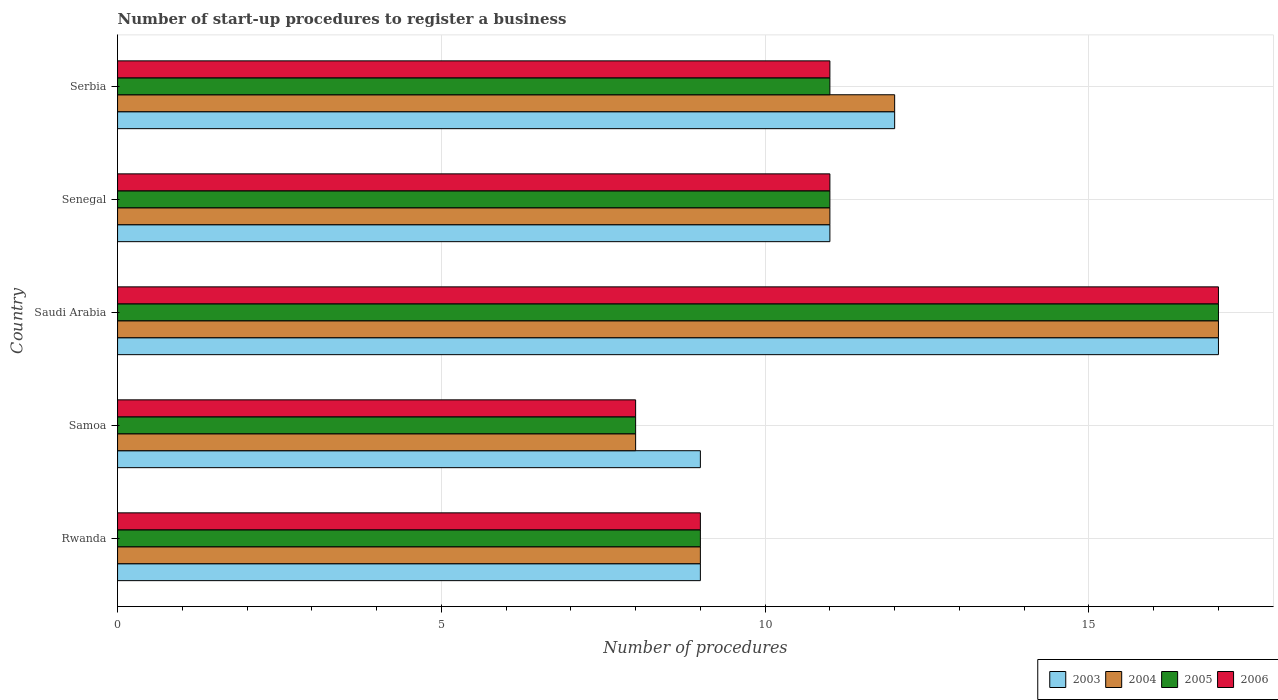How many different coloured bars are there?
Provide a succinct answer. 4. How many groups of bars are there?
Make the answer very short. 5. Are the number of bars per tick equal to the number of legend labels?
Keep it short and to the point. Yes. Are the number of bars on each tick of the Y-axis equal?
Offer a very short reply. Yes. How many bars are there on the 1st tick from the bottom?
Your answer should be very brief. 4. What is the label of the 3rd group of bars from the top?
Your response must be concise. Saudi Arabia. In how many cases, is the number of bars for a given country not equal to the number of legend labels?
Your answer should be very brief. 0. What is the number of procedures required to register a business in 2004 in Rwanda?
Provide a succinct answer. 9. In which country was the number of procedures required to register a business in 2006 maximum?
Make the answer very short. Saudi Arabia. In which country was the number of procedures required to register a business in 2006 minimum?
Give a very brief answer. Samoa. What is the difference between the number of procedures required to register a business in 2006 in Rwanda and that in Saudi Arabia?
Ensure brevity in your answer.  -8. What is the average number of procedures required to register a business in 2006 per country?
Your response must be concise. 11.2. What is the ratio of the number of procedures required to register a business in 2005 in Samoa to that in Serbia?
Offer a very short reply. 0.73. Is the number of procedures required to register a business in 2006 in Samoa less than that in Saudi Arabia?
Your answer should be very brief. Yes. Is the difference between the number of procedures required to register a business in 2005 in Samoa and Saudi Arabia greater than the difference between the number of procedures required to register a business in 2004 in Samoa and Saudi Arabia?
Offer a very short reply. No. What is the difference between the highest and the second highest number of procedures required to register a business in 2003?
Offer a very short reply. 5. What is the difference between the highest and the lowest number of procedures required to register a business in 2003?
Ensure brevity in your answer.  8. In how many countries, is the number of procedures required to register a business in 2003 greater than the average number of procedures required to register a business in 2003 taken over all countries?
Your answer should be very brief. 2. How many bars are there?
Provide a succinct answer. 20. What is the difference between two consecutive major ticks on the X-axis?
Your response must be concise. 5. Are the values on the major ticks of X-axis written in scientific E-notation?
Give a very brief answer. No. Does the graph contain grids?
Provide a short and direct response. Yes. Where does the legend appear in the graph?
Offer a terse response. Bottom right. How many legend labels are there?
Your response must be concise. 4. How are the legend labels stacked?
Give a very brief answer. Horizontal. What is the title of the graph?
Your answer should be very brief. Number of start-up procedures to register a business. Does "1974" appear as one of the legend labels in the graph?
Offer a terse response. No. What is the label or title of the X-axis?
Your answer should be compact. Number of procedures. What is the Number of procedures in 2006 in Rwanda?
Offer a terse response. 9. What is the Number of procedures of 2005 in Samoa?
Your response must be concise. 8. What is the Number of procedures in 2003 in Saudi Arabia?
Provide a succinct answer. 17. What is the Number of procedures of 2006 in Saudi Arabia?
Offer a very short reply. 17. What is the Number of procedures of 2004 in Serbia?
Offer a terse response. 12. Across all countries, what is the maximum Number of procedures of 2003?
Offer a terse response. 17. Across all countries, what is the maximum Number of procedures in 2004?
Your answer should be very brief. 17. Across all countries, what is the maximum Number of procedures of 2005?
Your answer should be very brief. 17. Across all countries, what is the maximum Number of procedures of 2006?
Provide a succinct answer. 17. Across all countries, what is the minimum Number of procedures of 2003?
Offer a terse response. 9. Across all countries, what is the minimum Number of procedures in 2005?
Give a very brief answer. 8. Across all countries, what is the minimum Number of procedures of 2006?
Offer a very short reply. 8. What is the total Number of procedures in 2006 in the graph?
Your answer should be compact. 56. What is the difference between the Number of procedures of 2004 in Rwanda and that in Samoa?
Keep it short and to the point. 1. What is the difference between the Number of procedures of 2005 in Rwanda and that in Samoa?
Ensure brevity in your answer.  1. What is the difference between the Number of procedures in 2006 in Rwanda and that in Samoa?
Ensure brevity in your answer.  1. What is the difference between the Number of procedures in 2006 in Rwanda and that in Saudi Arabia?
Offer a terse response. -8. What is the difference between the Number of procedures in 2003 in Rwanda and that in Senegal?
Your response must be concise. -2. What is the difference between the Number of procedures of 2004 in Rwanda and that in Senegal?
Ensure brevity in your answer.  -2. What is the difference between the Number of procedures in 2005 in Rwanda and that in Senegal?
Your answer should be compact. -2. What is the difference between the Number of procedures of 2004 in Rwanda and that in Serbia?
Give a very brief answer. -3. What is the difference between the Number of procedures in 2005 in Rwanda and that in Serbia?
Keep it short and to the point. -2. What is the difference between the Number of procedures in 2006 in Rwanda and that in Serbia?
Give a very brief answer. -2. What is the difference between the Number of procedures in 2005 in Samoa and that in Saudi Arabia?
Offer a terse response. -9. What is the difference between the Number of procedures in 2004 in Samoa and that in Senegal?
Provide a short and direct response. -3. What is the difference between the Number of procedures in 2005 in Samoa and that in Senegal?
Provide a short and direct response. -3. What is the difference between the Number of procedures in 2006 in Samoa and that in Senegal?
Make the answer very short. -3. What is the difference between the Number of procedures of 2004 in Samoa and that in Serbia?
Offer a terse response. -4. What is the difference between the Number of procedures in 2006 in Samoa and that in Serbia?
Provide a short and direct response. -3. What is the difference between the Number of procedures in 2004 in Saudi Arabia and that in Senegal?
Give a very brief answer. 6. What is the difference between the Number of procedures in 2005 in Saudi Arabia and that in Senegal?
Offer a terse response. 6. What is the difference between the Number of procedures of 2005 in Saudi Arabia and that in Serbia?
Make the answer very short. 6. What is the difference between the Number of procedures of 2006 in Saudi Arabia and that in Serbia?
Give a very brief answer. 6. What is the difference between the Number of procedures of 2005 in Senegal and that in Serbia?
Provide a short and direct response. 0. What is the difference between the Number of procedures in 2003 in Rwanda and the Number of procedures in 2004 in Samoa?
Keep it short and to the point. 1. What is the difference between the Number of procedures in 2003 in Rwanda and the Number of procedures in 2005 in Samoa?
Keep it short and to the point. 1. What is the difference between the Number of procedures of 2003 in Rwanda and the Number of procedures of 2006 in Samoa?
Offer a very short reply. 1. What is the difference between the Number of procedures of 2004 in Rwanda and the Number of procedures of 2006 in Samoa?
Your response must be concise. 1. What is the difference between the Number of procedures of 2003 in Rwanda and the Number of procedures of 2004 in Saudi Arabia?
Offer a very short reply. -8. What is the difference between the Number of procedures of 2003 in Rwanda and the Number of procedures of 2005 in Saudi Arabia?
Make the answer very short. -8. What is the difference between the Number of procedures in 2004 in Rwanda and the Number of procedures in 2005 in Saudi Arabia?
Provide a short and direct response. -8. What is the difference between the Number of procedures in 2005 in Rwanda and the Number of procedures in 2006 in Saudi Arabia?
Your answer should be compact. -8. What is the difference between the Number of procedures of 2003 in Rwanda and the Number of procedures of 2004 in Senegal?
Make the answer very short. -2. What is the difference between the Number of procedures of 2004 in Rwanda and the Number of procedures of 2005 in Senegal?
Give a very brief answer. -2. What is the difference between the Number of procedures in 2004 in Rwanda and the Number of procedures in 2006 in Senegal?
Give a very brief answer. -2. What is the difference between the Number of procedures in 2005 in Rwanda and the Number of procedures in 2006 in Senegal?
Offer a very short reply. -2. What is the difference between the Number of procedures in 2003 in Rwanda and the Number of procedures in 2004 in Serbia?
Your answer should be compact. -3. What is the difference between the Number of procedures of 2003 in Rwanda and the Number of procedures of 2005 in Serbia?
Offer a very short reply. -2. What is the difference between the Number of procedures in 2004 in Rwanda and the Number of procedures in 2005 in Serbia?
Offer a very short reply. -2. What is the difference between the Number of procedures of 2004 in Rwanda and the Number of procedures of 2006 in Serbia?
Provide a short and direct response. -2. What is the difference between the Number of procedures of 2005 in Rwanda and the Number of procedures of 2006 in Serbia?
Offer a very short reply. -2. What is the difference between the Number of procedures of 2003 in Samoa and the Number of procedures of 2006 in Saudi Arabia?
Your answer should be compact. -8. What is the difference between the Number of procedures in 2004 in Samoa and the Number of procedures in 2005 in Saudi Arabia?
Ensure brevity in your answer.  -9. What is the difference between the Number of procedures in 2003 in Samoa and the Number of procedures in 2005 in Senegal?
Your response must be concise. -2. What is the difference between the Number of procedures of 2005 in Samoa and the Number of procedures of 2006 in Senegal?
Offer a very short reply. -3. What is the difference between the Number of procedures of 2003 in Samoa and the Number of procedures of 2006 in Serbia?
Provide a short and direct response. -2. What is the difference between the Number of procedures of 2004 in Samoa and the Number of procedures of 2005 in Serbia?
Offer a terse response. -3. What is the difference between the Number of procedures in 2004 in Samoa and the Number of procedures in 2006 in Serbia?
Provide a succinct answer. -3. What is the difference between the Number of procedures of 2005 in Samoa and the Number of procedures of 2006 in Serbia?
Give a very brief answer. -3. What is the difference between the Number of procedures in 2003 in Saudi Arabia and the Number of procedures in 2006 in Senegal?
Your response must be concise. 6. What is the difference between the Number of procedures in 2005 in Saudi Arabia and the Number of procedures in 2006 in Senegal?
Provide a succinct answer. 6. What is the difference between the Number of procedures in 2003 in Saudi Arabia and the Number of procedures in 2004 in Serbia?
Your answer should be compact. 5. What is the difference between the Number of procedures of 2003 in Saudi Arabia and the Number of procedures of 2005 in Serbia?
Provide a succinct answer. 6. What is the difference between the Number of procedures in 2004 in Saudi Arabia and the Number of procedures in 2005 in Serbia?
Your answer should be compact. 6. What is the difference between the Number of procedures in 2004 in Saudi Arabia and the Number of procedures in 2006 in Serbia?
Your answer should be compact. 6. What is the difference between the Number of procedures of 2005 in Saudi Arabia and the Number of procedures of 2006 in Serbia?
Make the answer very short. 6. What is the difference between the Number of procedures in 2003 in Senegal and the Number of procedures in 2004 in Serbia?
Provide a succinct answer. -1. What is the difference between the Number of procedures of 2003 in Senegal and the Number of procedures of 2005 in Serbia?
Provide a short and direct response. 0. What is the difference between the Number of procedures in 2003 in Senegal and the Number of procedures in 2006 in Serbia?
Give a very brief answer. 0. What is the difference between the Number of procedures in 2005 in Senegal and the Number of procedures in 2006 in Serbia?
Offer a terse response. 0. What is the average Number of procedures of 2003 per country?
Give a very brief answer. 11.6. What is the average Number of procedures in 2004 per country?
Give a very brief answer. 11.4. What is the average Number of procedures of 2006 per country?
Keep it short and to the point. 11.2. What is the difference between the Number of procedures of 2003 and Number of procedures of 2005 in Rwanda?
Give a very brief answer. 0. What is the difference between the Number of procedures in 2004 and Number of procedures in 2005 in Rwanda?
Ensure brevity in your answer.  0. What is the difference between the Number of procedures of 2003 and Number of procedures of 2006 in Samoa?
Your answer should be very brief. 1. What is the difference between the Number of procedures in 2003 and Number of procedures in 2005 in Saudi Arabia?
Offer a terse response. 0. What is the difference between the Number of procedures of 2003 and Number of procedures of 2006 in Saudi Arabia?
Your answer should be compact. 0. What is the difference between the Number of procedures in 2004 and Number of procedures in 2005 in Saudi Arabia?
Provide a short and direct response. 0. What is the difference between the Number of procedures of 2003 and Number of procedures of 2005 in Senegal?
Offer a very short reply. 0. What is the difference between the Number of procedures of 2003 and Number of procedures of 2006 in Senegal?
Your response must be concise. 0. What is the difference between the Number of procedures of 2004 and Number of procedures of 2005 in Senegal?
Offer a very short reply. 0. What is the difference between the Number of procedures of 2004 and Number of procedures of 2006 in Senegal?
Offer a terse response. 0. What is the difference between the Number of procedures in 2003 and Number of procedures in 2004 in Serbia?
Offer a very short reply. 0. What is the difference between the Number of procedures in 2003 and Number of procedures in 2005 in Serbia?
Your response must be concise. 1. What is the difference between the Number of procedures of 2003 and Number of procedures of 2006 in Serbia?
Make the answer very short. 1. What is the difference between the Number of procedures in 2004 and Number of procedures in 2005 in Serbia?
Your answer should be very brief. 1. What is the difference between the Number of procedures of 2005 and Number of procedures of 2006 in Serbia?
Keep it short and to the point. 0. What is the ratio of the Number of procedures of 2003 in Rwanda to that in Samoa?
Provide a short and direct response. 1. What is the ratio of the Number of procedures in 2006 in Rwanda to that in Samoa?
Provide a succinct answer. 1.12. What is the ratio of the Number of procedures in 2003 in Rwanda to that in Saudi Arabia?
Your answer should be compact. 0.53. What is the ratio of the Number of procedures of 2004 in Rwanda to that in Saudi Arabia?
Your answer should be compact. 0.53. What is the ratio of the Number of procedures in 2005 in Rwanda to that in Saudi Arabia?
Provide a short and direct response. 0.53. What is the ratio of the Number of procedures in 2006 in Rwanda to that in Saudi Arabia?
Give a very brief answer. 0.53. What is the ratio of the Number of procedures of 2003 in Rwanda to that in Senegal?
Make the answer very short. 0.82. What is the ratio of the Number of procedures in 2004 in Rwanda to that in Senegal?
Provide a short and direct response. 0.82. What is the ratio of the Number of procedures of 2005 in Rwanda to that in Senegal?
Offer a very short reply. 0.82. What is the ratio of the Number of procedures of 2006 in Rwanda to that in Senegal?
Your response must be concise. 0.82. What is the ratio of the Number of procedures in 2004 in Rwanda to that in Serbia?
Provide a short and direct response. 0.75. What is the ratio of the Number of procedures of 2005 in Rwanda to that in Serbia?
Your response must be concise. 0.82. What is the ratio of the Number of procedures of 2006 in Rwanda to that in Serbia?
Offer a terse response. 0.82. What is the ratio of the Number of procedures of 2003 in Samoa to that in Saudi Arabia?
Keep it short and to the point. 0.53. What is the ratio of the Number of procedures of 2004 in Samoa to that in Saudi Arabia?
Keep it short and to the point. 0.47. What is the ratio of the Number of procedures of 2005 in Samoa to that in Saudi Arabia?
Offer a very short reply. 0.47. What is the ratio of the Number of procedures of 2006 in Samoa to that in Saudi Arabia?
Offer a very short reply. 0.47. What is the ratio of the Number of procedures of 2003 in Samoa to that in Senegal?
Make the answer very short. 0.82. What is the ratio of the Number of procedures of 2004 in Samoa to that in Senegal?
Provide a short and direct response. 0.73. What is the ratio of the Number of procedures in 2005 in Samoa to that in Senegal?
Make the answer very short. 0.73. What is the ratio of the Number of procedures in 2006 in Samoa to that in Senegal?
Give a very brief answer. 0.73. What is the ratio of the Number of procedures of 2004 in Samoa to that in Serbia?
Provide a short and direct response. 0.67. What is the ratio of the Number of procedures of 2005 in Samoa to that in Serbia?
Provide a succinct answer. 0.73. What is the ratio of the Number of procedures in 2006 in Samoa to that in Serbia?
Your answer should be compact. 0.73. What is the ratio of the Number of procedures of 2003 in Saudi Arabia to that in Senegal?
Provide a succinct answer. 1.55. What is the ratio of the Number of procedures of 2004 in Saudi Arabia to that in Senegal?
Keep it short and to the point. 1.55. What is the ratio of the Number of procedures in 2005 in Saudi Arabia to that in Senegal?
Ensure brevity in your answer.  1.55. What is the ratio of the Number of procedures of 2006 in Saudi Arabia to that in Senegal?
Keep it short and to the point. 1.55. What is the ratio of the Number of procedures of 2003 in Saudi Arabia to that in Serbia?
Your answer should be compact. 1.42. What is the ratio of the Number of procedures in 2004 in Saudi Arabia to that in Serbia?
Your answer should be compact. 1.42. What is the ratio of the Number of procedures in 2005 in Saudi Arabia to that in Serbia?
Your answer should be compact. 1.55. What is the ratio of the Number of procedures in 2006 in Saudi Arabia to that in Serbia?
Your answer should be compact. 1.55. What is the ratio of the Number of procedures in 2003 in Senegal to that in Serbia?
Your answer should be very brief. 0.92. What is the ratio of the Number of procedures of 2005 in Senegal to that in Serbia?
Keep it short and to the point. 1. What is the difference between the highest and the second highest Number of procedures of 2004?
Provide a succinct answer. 5. What is the difference between the highest and the lowest Number of procedures of 2003?
Your answer should be very brief. 8. What is the difference between the highest and the lowest Number of procedures of 2004?
Keep it short and to the point. 9. 